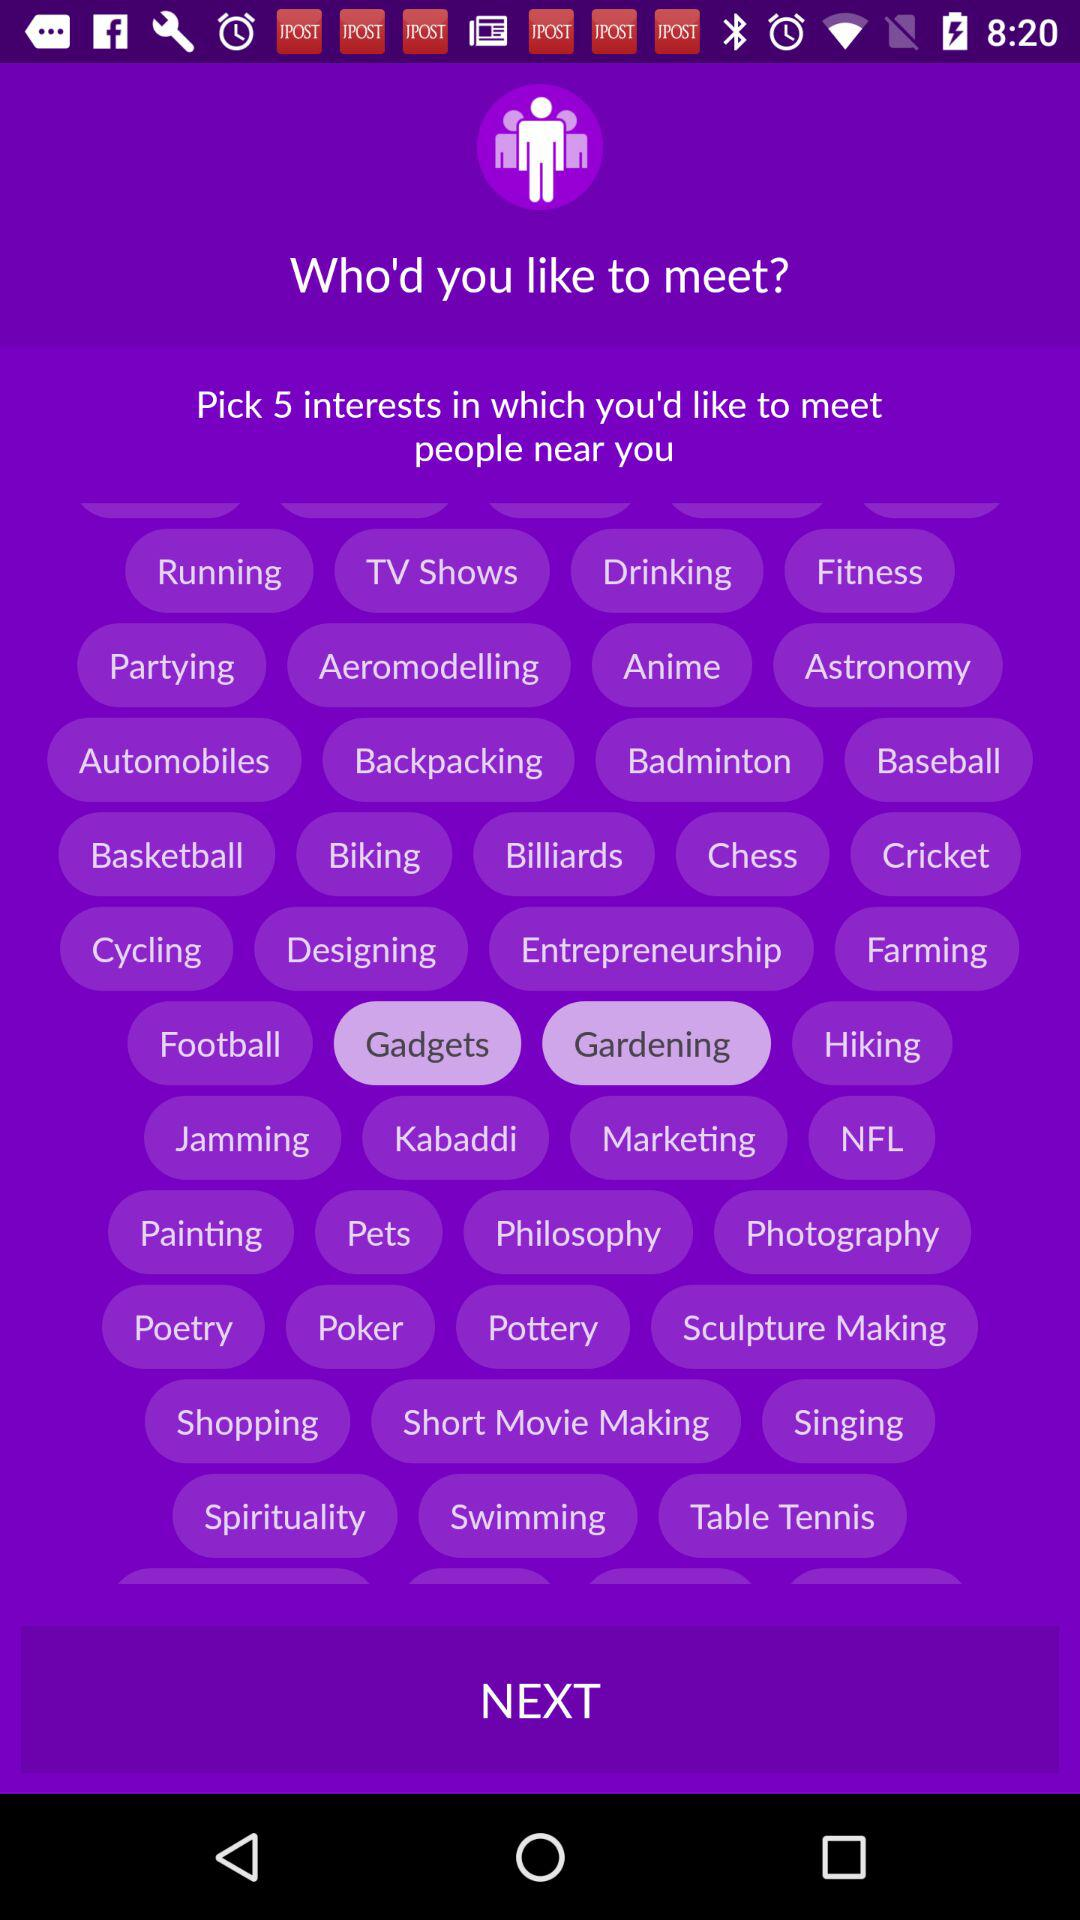Which option has been selected? The selected options are "Gadgets" and "Gardening". 